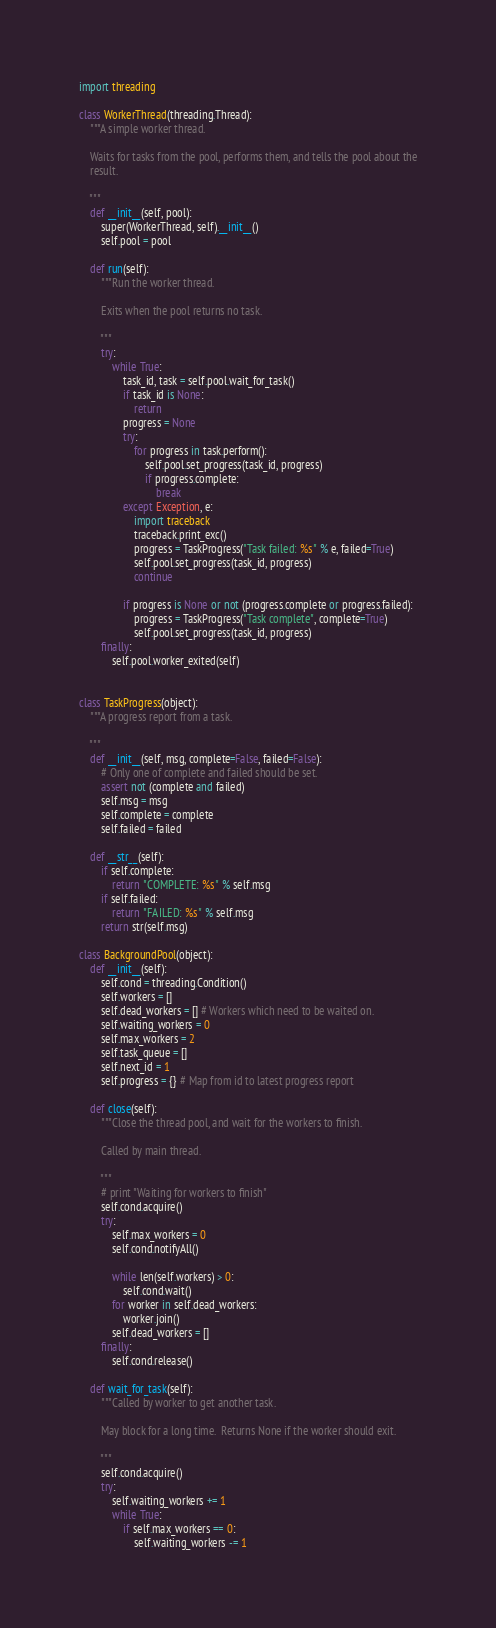<code> <loc_0><loc_0><loc_500><loc_500><_Python_>import threading

class WorkerThread(threading.Thread):
    """A simple worker thread.

    Waits for tasks from the pool, performs them, and tells the pool about the
    result.

    """
    def __init__(self, pool):
        super(WorkerThread, self).__init__()
        self.pool = pool

    def run(self):
        """Run the worker thread.

        Exits when the pool returns no task.

        """
        try:
            while True:
                task_id, task = self.pool.wait_for_task()
                if task_id is None:
                    return
                progress = None
                try:
                    for progress in task.perform():
                        self.pool.set_progress(task_id, progress)
                        if progress.complete:
                            break
                except Exception, e:
                    import traceback
                    traceback.print_exc()
                    progress = TaskProgress("Task failed: %s" % e, failed=True)
                    self.pool.set_progress(task_id, progress)
                    continue

                if progress is None or not (progress.complete or progress.failed):
                    progress = TaskProgress("Task complete", complete=True)
                    self.pool.set_progress(task_id, progress)
        finally:
            self.pool.worker_exited(self)


class TaskProgress(object):
    """A progress report from a task.

    """
    def __init__(self, msg, complete=False, failed=False):
        # Only one of complete and failed should be set.
        assert not (complete and failed)
        self.msg = msg
        self.complete = complete
        self.failed = failed

    def __str__(self):
        if self.complete:
            return "COMPLETE: %s" % self.msg
        if self.failed:
            return "FAILED: %s" % self.msg
        return str(self.msg)

class BackgroundPool(object):
    def __init__(self):
        self.cond = threading.Condition()
        self.workers = []
        self.dead_workers = [] # Workers which need to be waited on.
        self.waiting_workers = 0
        self.max_workers = 2
        self.task_queue = []
        self.next_id = 1
        self.progress = {} # Map from id to latest progress report

    def close(self):
        """Close the thread pool, and wait for the workers to finish.

        Called by main thread.
        
        """
        # print "Waiting for workers to finish"
        self.cond.acquire()
        try:
            self.max_workers = 0
            self.cond.notifyAll()

            while len(self.workers) > 0:
                self.cond.wait()
            for worker in self.dead_workers:
                worker.join()
            self.dead_workers = []
        finally:
            self.cond.release()
                
    def wait_for_task(self):
        """Called by worker to get another task.

        May block for a long time.  Returns None if the worker should exit.

        """
        self.cond.acquire()
        try:
            self.waiting_workers += 1
            while True:
                if self.max_workers == 0:
                    self.waiting_workers -= 1</code> 